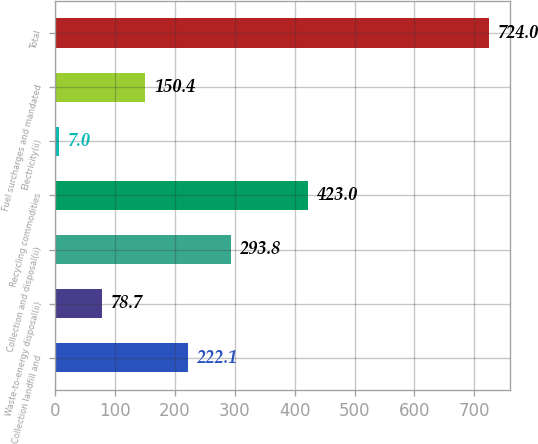Convert chart to OTSL. <chart><loc_0><loc_0><loc_500><loc_500><bar_chart><fcel>Collection landfill and<fcel>Waste-to-energy disposal(ii)<fcel>Collection and disposal(ii)<fcel>Recycling commodities<fcel>Electricity(ii)<fcel>Fuel surcharges and mandated<fcel>Total<nl><fcel>222.1<fcel>78.7<fcel>293.8<fcel>423<fcel>7<fcel>150.4<fcel>724<nl></chart> 